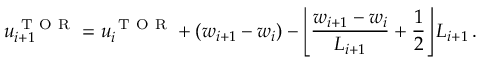<formula> <loc_0><loc_0><loc_500><loc_500>u _ { i + 1 } ^ { T O R } = u _ { i } ^ { T O R } + ( w _ { i + 1 } - w _ { i } ) - \left \lfloor \frac { w _ { i + 1 } - w _ { i } } { L _ { i + 1 } } + \frac { 1 } { 2 } \right \rfloor L _ { i + 1 } \, .</formula> 